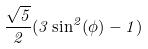<formula> <loc_0><loc_0><loc_500><loc_500>\frac { \sqrt { 5 } } { 2 } ( 3 \sin ^ { 2 } ( \phi ) - 1 )</formula> 